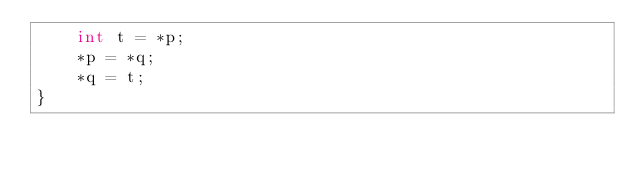<code> <loc_0><loc_0><loc_500><loc_500><_C++_>	int t = *p;
	*p = *q;
	*q = t;
}
</code> 